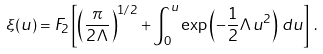Convert formula to latex. <formula><loc_0><loc_0><loc_500><loc_500>\xi ( u ) = F _ { 2 } \left [ \left ( \frac { \pi } { 2 \Lambda } \right ) ^ { 1 / 2 } + \int _ { 0 } ^ { u } \exp \left ( - \frac { 1 } { 2 } \Lambda u ^ { 2 } \right ) \, d u \right ] \, .</formula> 